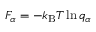Convert formula to latex. <formula><loc_0><loc_0><loc_500><loc_500>F _ { \alpha } = - k _ { B } T \ln q _ { \alpha }</formula> 